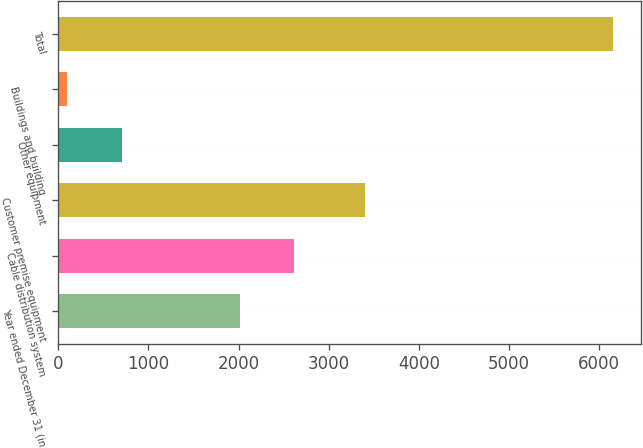Convert chart. <chart><loc_0><loc_0><loc_500><loc_500><bar_chart><fcel>Year ended December 31 (in<fcel>Cable distribution system<fcel>Customer premise equipment<fcel>Other equipment<fcel>Buildings and building<fcel>Total<nl><fcel>2014<fcel>2619.7<fcel>3397<fcel>702.7<fcel>97<fcel>6154<nl></chart> 